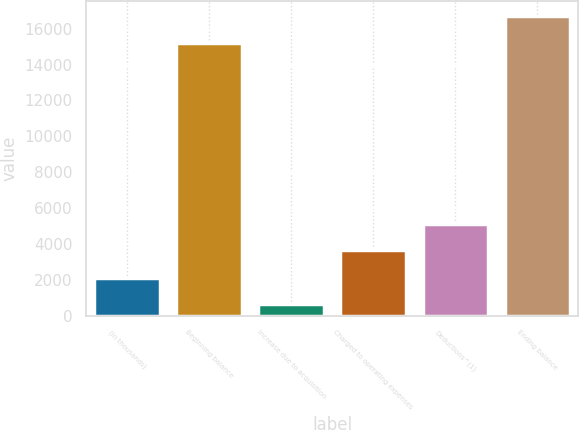Convert chart. <chart><loc_0><loc_0><loc_500><loc_500><bar_chart><fcel>(in thousands)<fcel>Beginning balance<fcel>Increase due to acquisition<fcel>Charged to operating expenses<fcel>Deductions^(1)<fcel>Ending balance<nl><fcel>2119.1<fcel>15225<fcel>662<fcel>3673<fcel>5130.1<fcel>16682.1<nl></chart> 